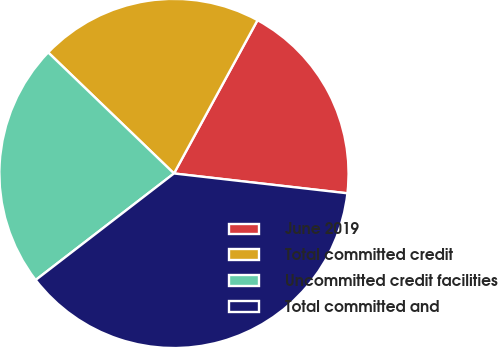Convert chart to OTSL. <chart><loc_0><loc_0><loc_500><loc_500><pie_chart><fcel>June 2019<fcel>Total committed credit<fcel>Uncommitted credit facilities<fcel>Total committed and<nl><fcel>18.87%<fcel>20.75%<fcel>22.64%<fcel>37.74%<nl></chart> 